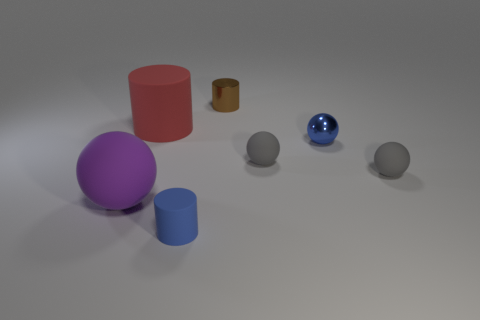Subtract all blue spheres. How many spheres are left? 3 Add 2 red cylinders. How many objects exist? 9 Subtract all red cylinders. How many cylinders are left? 2 Subtract all cylinders. How many objects are left? 4 Add 5 tiny matte things. How many tiny matte things exist? 8 Subtract 1 blue balls. How many objects are left? 6 Subtract 1 cylinders. How many cylinders are left? 2 Subtract all cyan balls. Subtract all gray cylinders. How many balls are left? 4 Subtract all yellow spheres. How many red cylinders are left? 1 Subtract all big purple matte spheres. Subtract all gray balls. How many objects are left? 4 